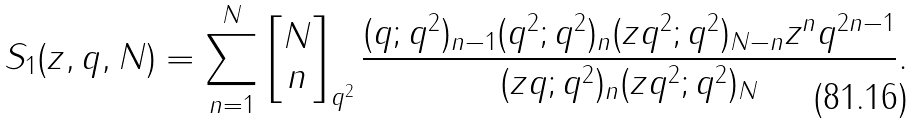<formula> <loc_0><loc_0><loc_500><loc_500>S _ { 1 } ( z , q , N ) = \sum _ { n = 1 } ^ { N } \left [ \begin{matrix} N \\ n \end{matrix} \right ] _ { q ^ { 2 } } \frac { ( q ; q ^ { 2 } ) _ { n - 1 } ( q ^ { 2 } ; q ^ { 2 } ) _ { n } ( z q ^ { 2 } ; q ^ { 2 } ) _ { N - n } z ^ { n } q ^ { 2 n - 1 } } { ( z q ; q ^ { 2 } ) _ { n } ( z q ^ { 2 } ; q ^ { 2 } ) _ { N } } .</formula> 